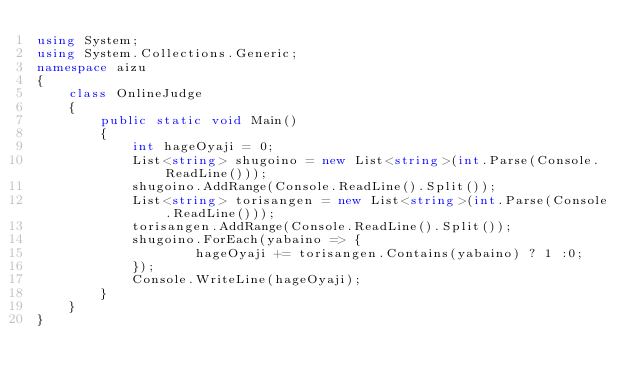Convert code to text. <code><loc_0><loc_0><loc_500><loc_500><_C#_>using System;
using System.Collections.Generic;
namespace aizu
{
    class OnlineJudge
    {
        public static void Main()
        {
            int hageOyaji = 0;
            List<string> shugoino = new List<string>(int.Parse(Console.ReadLine()));
            shugoino.AddRange(Console.ReadLine().Split());
            List<string> torisangen = new List<string>(int.Parse(Console.ReadLine()));
            torisangen.AddRange(Console.ReadLine().Split());
            shugoino.ForEach(yabaino => {
                    hageOyaji += torisangen.Contains(yabaino) ? 1 :0;
            });
            Console.WriteLine(hageOyaji);
        }
    }
}</code> 